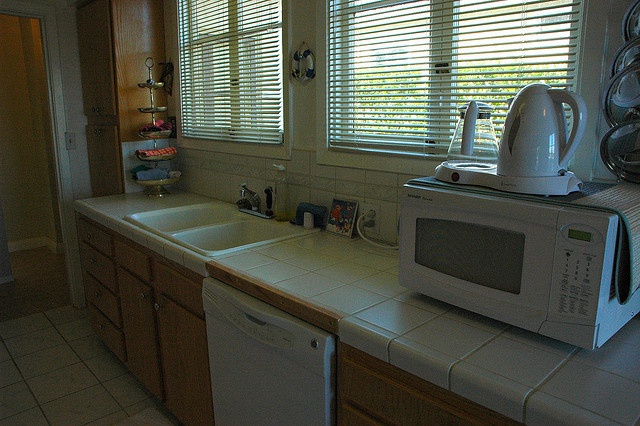Describe the objects in this image and their specific colors. I can see microwave in black tones, refrigerator in black tones, and sink in black, darkgreen, and gray tones in this image. 